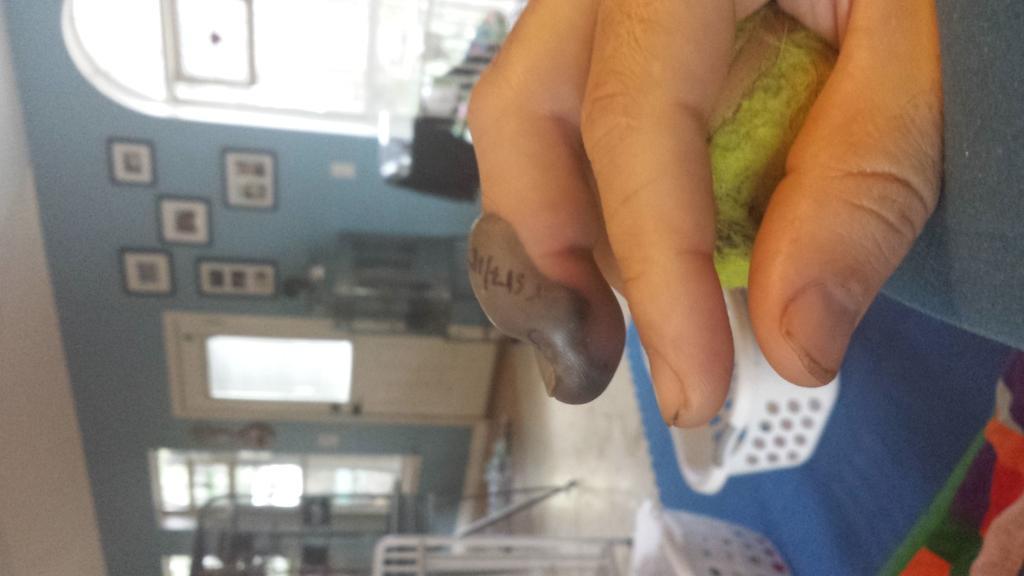Can you describe this image briefly? In this image I can see the person holding the ball and I can see few baskets. In the background I can see few frames attached to the wall and the wall is in blue color and I can also see few windows. 